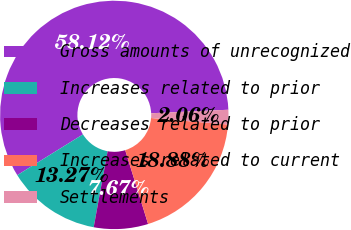Convert chart. <chart><loc_0><loc_0><loc_500><loc_500><pie_chart><fcel>Gross amounts of unrecognized<fcel>Increases related to prior<fcel>Decreases related to prior<fcel>Increases related to current<fcel>Settlements<nl><fcel>58.12%<fcel>13.27%<fcel>7.67%<fcel>18.88%<fcel>2.06%<nl></chart> 